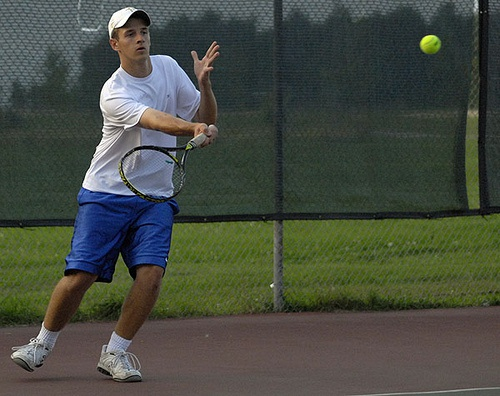Describe the objects in this image and their specific colors. I can see people in gray, black, navy, and darkgray tones, tennis racket in gray, black, and darkgray tones, and sports ball in gray, darkgreen, olive, and yellow tones in this image. 